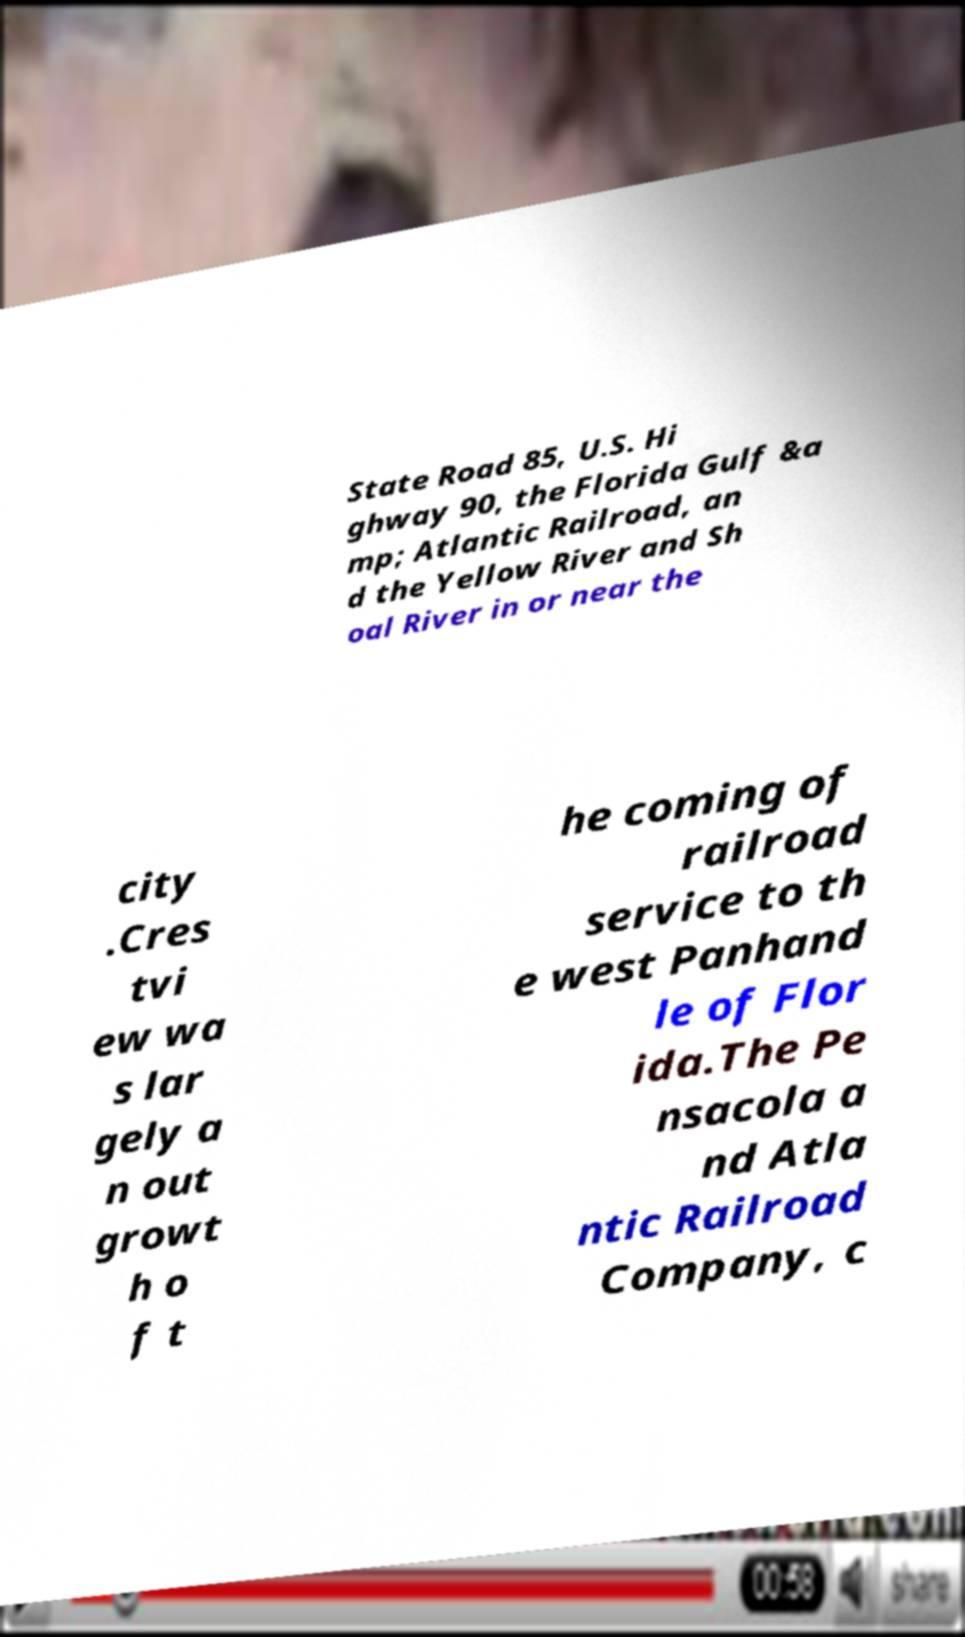Please identify and transcribe the text found in this image. State Road 85, U.S. Hi ghway 90, the Florida Gulf &a mp; Atlantic Railroad, an d the Yellow River and Sh oal River in or near the city .Cres tvi ew wa s lar gely a n out growt h o f t he coming of railroad service to th e west Panhand le of Flor ida.The Pe nsacola a nd Atla ntic Railroad Company, c 